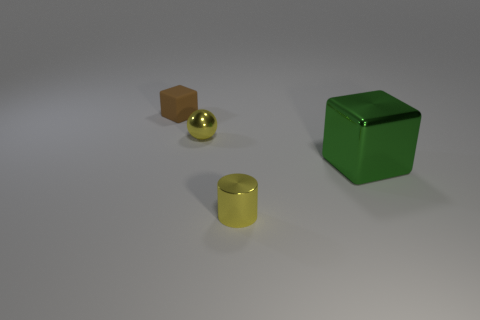Does the yellow sphere have the same size as the brown thing?
Give a very brief answer. Yes. How many objects are either metal blocks or small blue spheres?
Provide a short and direct response. 1. There is a cube behind the cube in front of the small brown thing; what is its size?
Your response must be concise. Small. The brown matte thing has what size?
Your answer should be very brief. Small. What shape is the small thing that is left of the yellow shiny cylinder and in front of the brown rubber object?
Your response must be concise. Sphere. There is a shiny thing that is the same shape as the tiny brown rubber object; what color is it?
Provide a succinct answer. Green. How many things are objects that are to the right of the tiny matte cube or small objects right of the matte cube?
Offer a very short reply. 3. There is a big green thing; what shape is it?
Your response must be concise. Cube. What shape is the thing that is the same color as the shiny cylinder?
Your answer should be very brief. Sphere. How many other tiny brown blocks are made of the same material as the tiny brown block?
Provide a short and direct response. 0. 